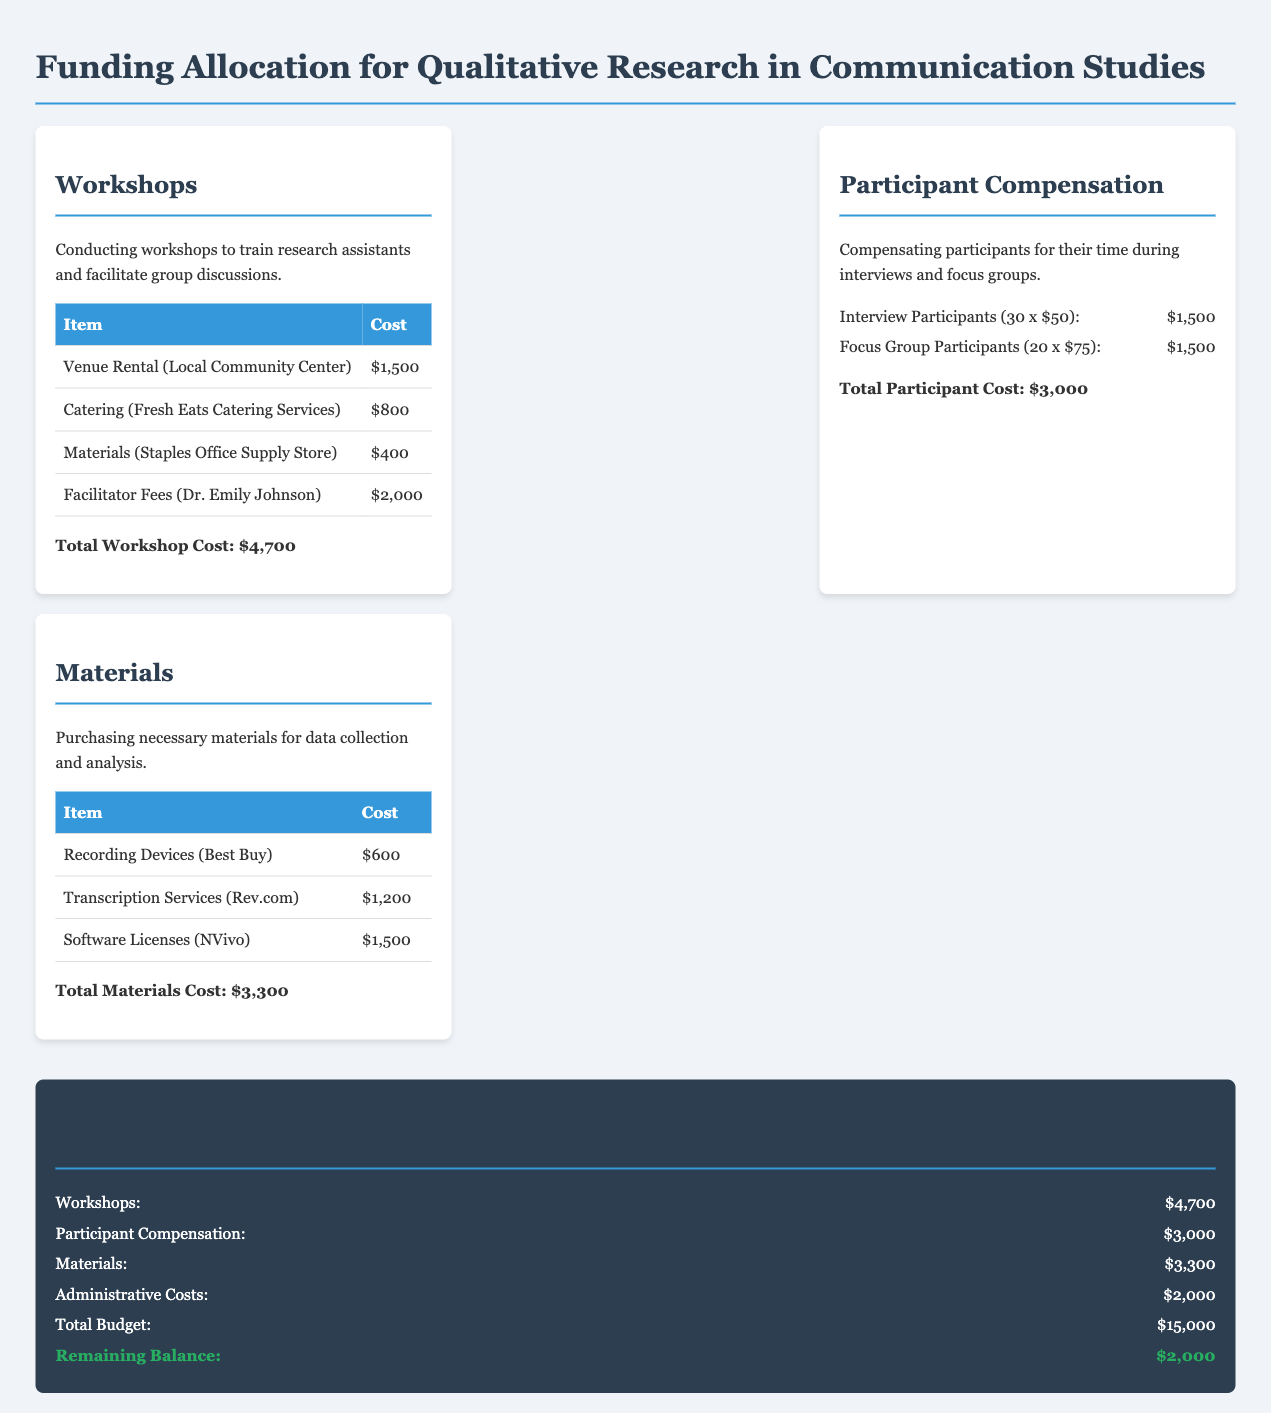What is the total cost for workshops? The total cost for workshops is clearly stated at the end of the section, which is $4,700.
Answer: $4,700 How much is allocated for participant compensation? The document specifies that the total participant cost is $3,000.
Answer: $3,000 Who is the facilitator for the workshops? The document names Dr. Emily Johnson as the facilitator for the workshops.
Answer: Dr. Emily Johnson What are the total expenses for materials? The total materials cost listed in the document is $3,300.
Answer: $3,300 What is the cost of the venue rental for the workshops? The document lists the venue rental cost as $1,500.
Answer: $1,500 How many interview participants are included in the compensation? The document states there are 30 interview participants for compensation.
Answer: 30 What is the total budget for the project? The total budget, as outlined in the budget summary, is $15,000.
Answer: $15,000 What amount is left in the remaining balance? The remaining balance is stated as $2,000 in the document.
Answer: $2,000 What is the cost for transcription services? The document lists the cost for transcription services as $1,200.
Answer: $1,200 